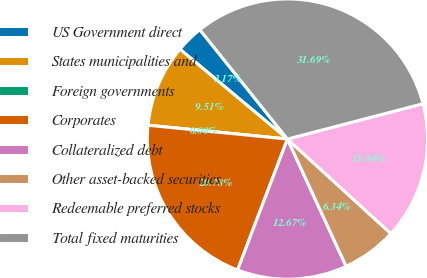<chart> <loc_0><loc_0><loc_500><loc_500><pie_chart><fcel>US Government direct<fcel>States municipalities and<fcel>Foreign governments<fcel>Corporates<fcel>Collateralized debt<fcel>Other asset-backed securities<fcel>Redeemable preferred stocks<fcel>Total fixed maturities<nl><fcel>3.17%<fcel>9.51%<fcel>0.0%<fcel>20.78%<fcel>12.67%<fcel>6.34%<fcel>15.84%<fcel>31.69%<nl></chart> 